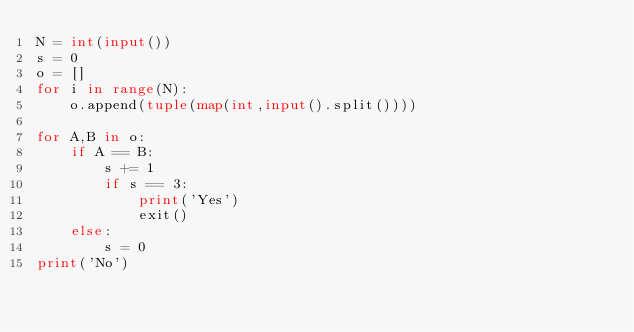Convert code to text. <code><loc_0><loc_0><loc_500><loc_500><_Python_>N = int(input())
s = 0
o = []
for i in range(N):
    o.append(tuple(map(int,input().split())))

for A,B in o:
    if A == B:
        s += 1
        if s == 3:
            print('Yes')
            exit()
    else:
        s = 0
print('No')</code> 